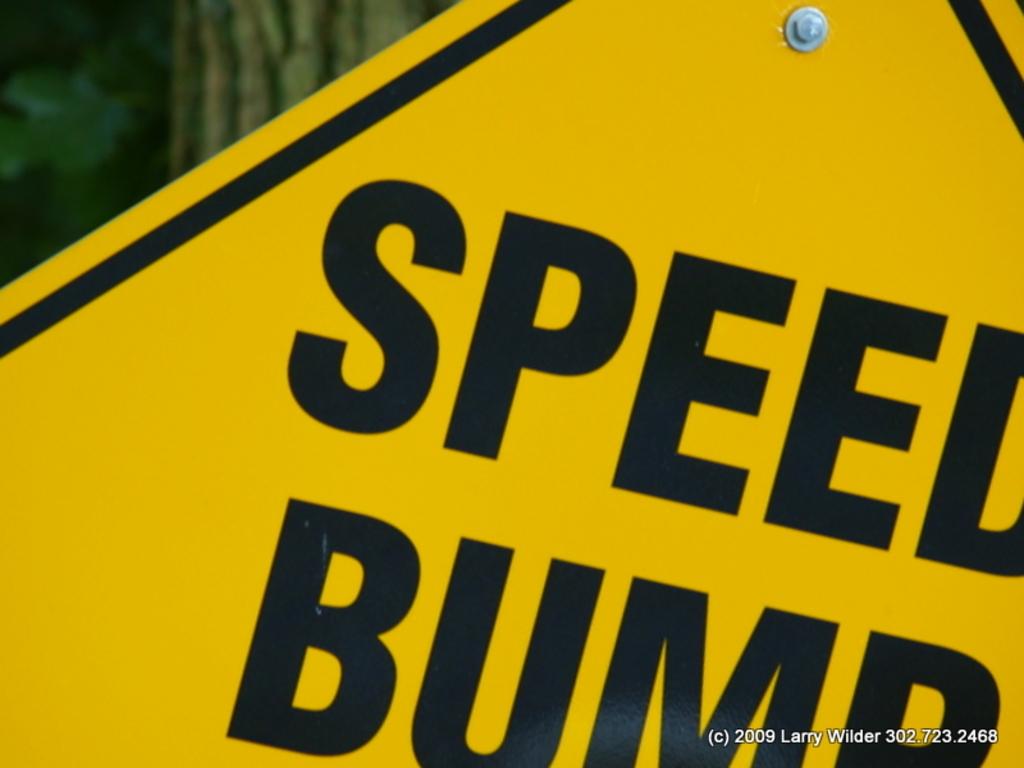What does this sign say?
Give a very brief answer. Speed bump. 